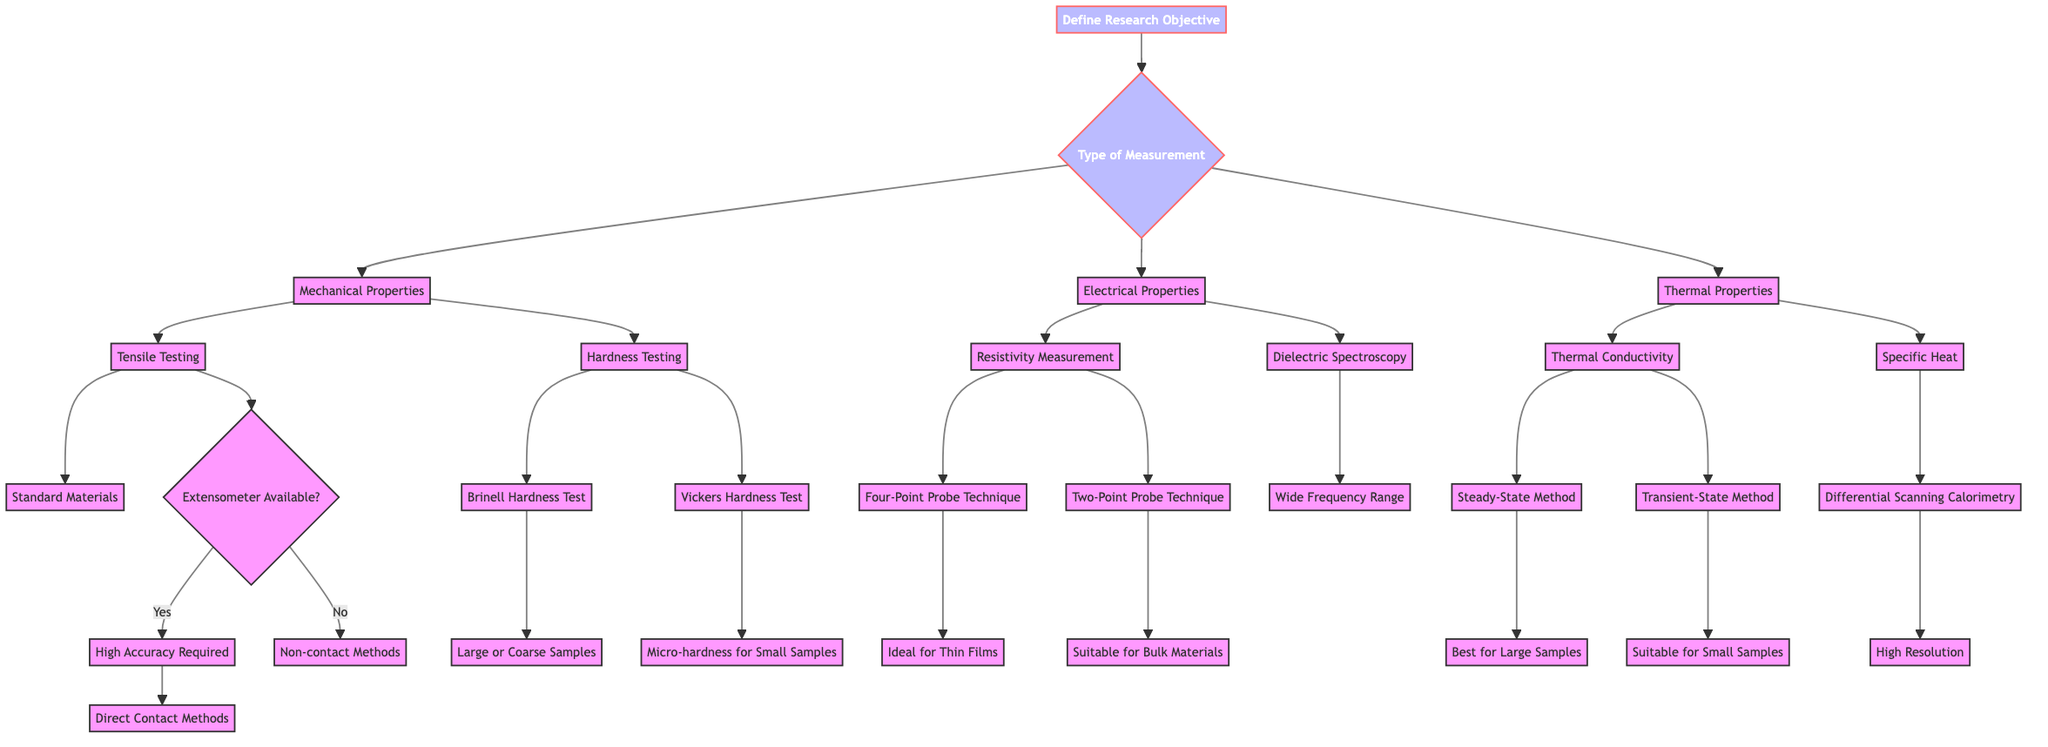What is the first step in the decision tree? The first step is defining the research objective, which is the initial node of the diagram.
Answer: Define Research Objective How many main types of measurement are defined? The diagram shows three main types of measurement: Mechanical Properties, Electrical Properties, and Thermal Properties.
Answer: Three What measurement technique is suggested for large or coarse samples? The diagram specifies that the Brinell Hardness Test is suitable for large or coarse samples.
Answer: Brinell Hardness Test Which method is ideal for thin films? The Four-Point Probe Technique is identified as ideal for thin films in the Electrical Properties section of the diagram.
Answer: Four-Point Probe Technique If an extensometer is not available, which method should be used for tensile testing? The diagram indicates that if an extensometer is not available, non-contact methods should be used for tensile testing.
Answer: Non-contact Methods What are the properties of the Differential Scanning Calorimetry technique? Differential Scanning Calorimetry is noted to have high resolution, as per the diagram in the context of specific heat measurement.
Answer: High Resolution What are the two methods listed under thermal conductivity? The Steady-State Method and the Transient-State Method are listed under thermal conductivity in the diagram.
Answer: Steady-State Method and Transient-State Method What is indicated under the category of electrical properties related to resistivity measurement? The resistivity measurement includes two techniques: Four-Point Probe Technique and Two-Point Probe Technique, as seen in the diagram.
Answer: Four-Point Probe Technique and Two-Point Probe Technique What is the decision point related to mechanical properties in tensile testing? The decision point for tensile testing is whether an extensometer is available or not, influencing the next steps in the diagram.
Answer: Extensometer Available 